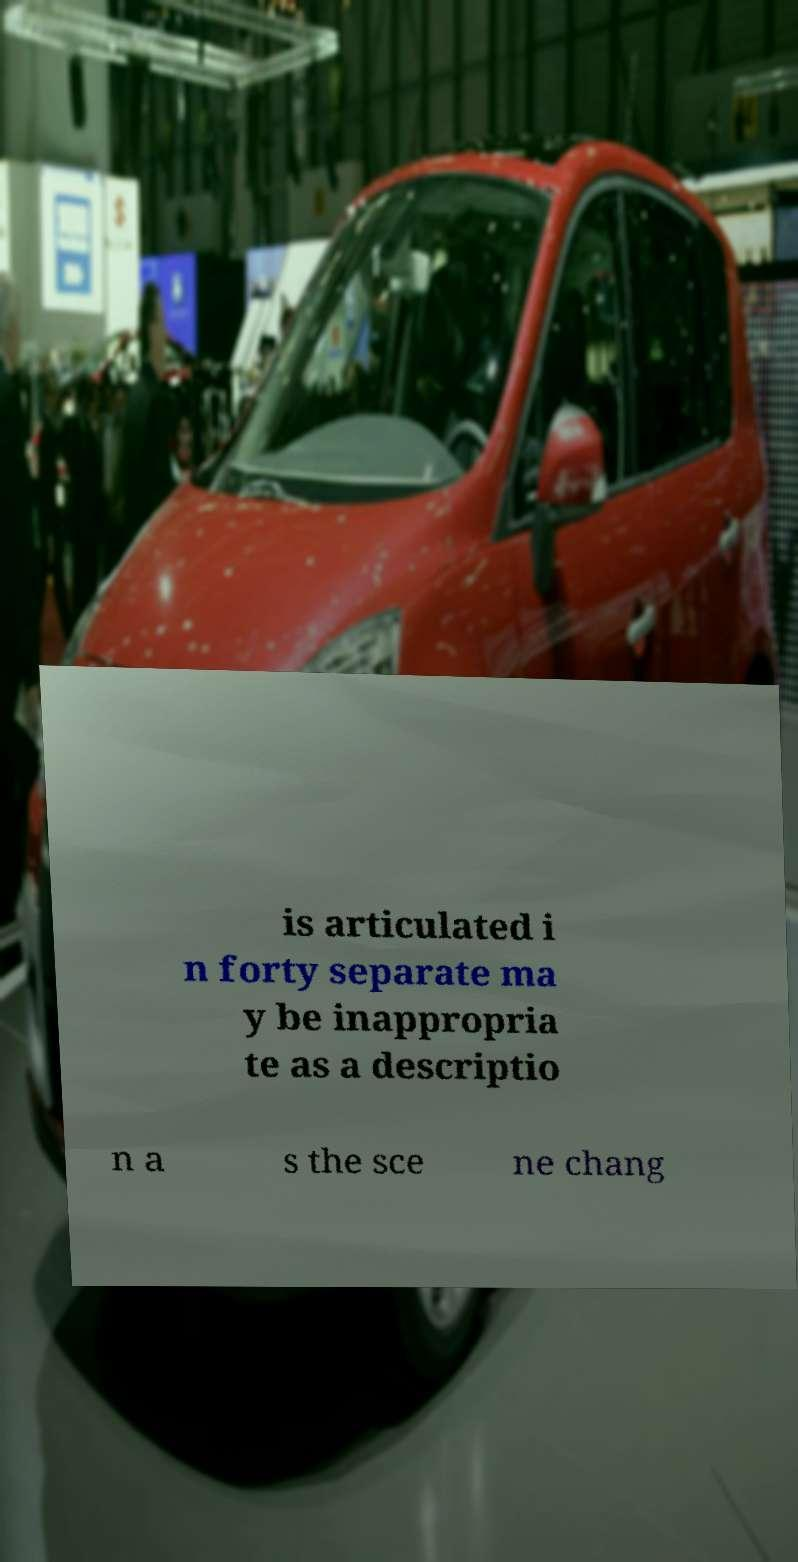Can you read and provide the text displayed in the image?This photo seems to have some interesting text. Can you extract and type it out for me? is articulated i n forty separate ma y be inappropria te as a descriptio n a s the sce ne chang 